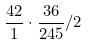<formula> <loc_0><loc_0><loc_500><loc_500>\frac { 4 2 } { 1 } \cdot \frac { 3 6 } { 2 4 5 } / 2</formula> 